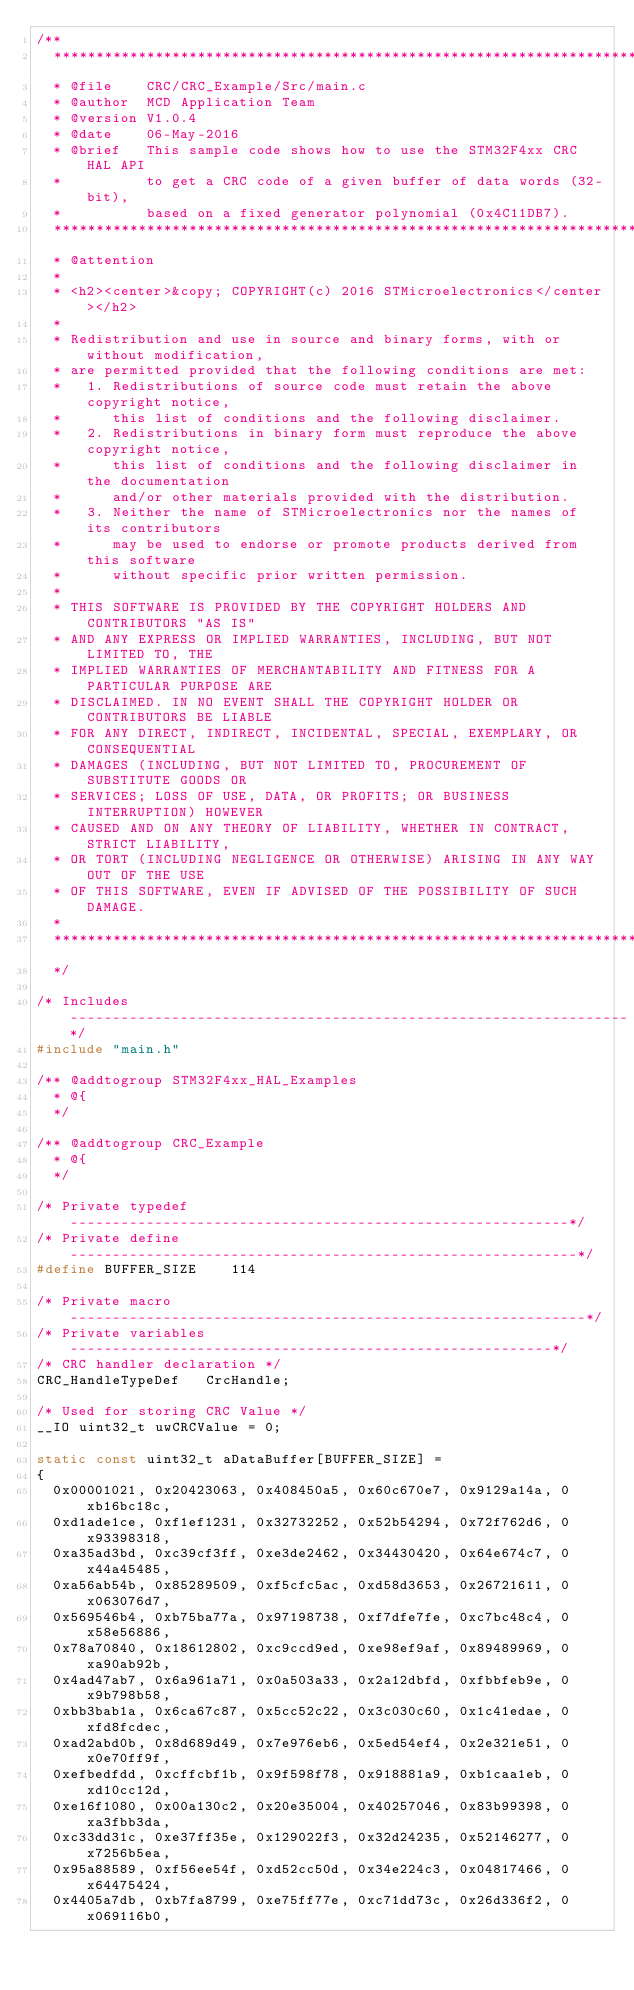Convert code to text. <code><loc_0><loc_0><loc_500><loc_500><_C_>/**
  ******************************************************************************
  * @file    CRC/CRC_Example/Src/main.c
  * @author  MCD Application Team
  * @version V1.0.4
  * @date    06-May-2016
  * @brief   This sample code shows how to use the STM32F4xx CRC HAL API
  *          to get a CRC code of a given buffer of data words (32-bit),
  *          based on a fixed generator polynomial (0x4C11DB7).
  ******************************************************************************
  * @attention
  *
  * <h2><center>&copy; COPYRIGHT(c) 2016 STMicroelectronics</center></h2>
  *
  * Redistribution and use in source and binary forms, with or without modification,
  * are permitted provided that the following conditions are met:
  *   1. Redistributions of source code must retain the above copyright notice,
  *      this list of conditions and the following disclaimer.
  *   2. Redistributions in binary form must reproduce the above copyright notice,
  *      this list of conditions and the following disclaimer in the documentation
  *      and/or other materials provided with the distribution.
  *   3. Neither the name of STMicroelectronics nor the names of its contributors
  *      may be used to endorse or promote products derived from this software
  *      without specific prior written permission.
  *
  * THIS SOFTWARE IS PROVIDED BY THE COPYRIGHT HOLDERS AND CONTRIBUTORS "AS IS"
  * AND ANY EXPRESS OR IMPLIED WARRANTIES, INCLUDING, BUT NOT LIMITED TO, THE
  * IMPLIED WARRANTIES OF MERCHANTABILITY AND FITNESS FOR A PARTICULAR PURPOSE ARE
  * DISCLAIMED. IN NO EVENT SHALL THE COPYRIGHT HOLDER OR CONTRIBUTORS BE LIABLE
  * FOR ANY DIRECT, INDIRECT, INCIDENTAL, SPECIAL, EXEMPLARY, OR CONSEQUENTIAL
  * DAMAGES (INCLUDING, BUT NOT LIMITED TO, PROCUREMENT OF SUBSTITUTE GOODS OR
  * SERVICES; LOSS OF USE, DATA, OR PROFITS; OR BUSINESS INTERRUPTION) HOWEVER
  * CAUSED AND ON ANY THEORY OF LIABILITY, WHETHER IN CONTRACT, STRICT LIABILITY,
  * OR TORT (INCLUDING NEGLIGENCE OR OTHERWISE) ARISING IN ANY WAY OUT OF THE USE
  * OF THIS SOFTWARE, EVEN IF ADVISED OF THE POSSIBILITY OF SUCH DAMAGE.
  *
  ******************************************************************************
  */

/* Includes ------------------------------------------------------------------*/
#include "main.h"

/** @addtogroup STM32F4xx_HAL_Examples
  * @{
  */

/** @addtogroup CRC_Example
  * @{
  */

/* Private typedef -----------------------------------------------------------*/
/* Private define ------------------------------------------------------------*/
#define BUFFER_SIZE    114

/* Private macro -------------------------------------------------------------*/
/* Private variables ---------------------------------------------------------*/
/* CRC handler declaration */
CRC_HandleTypeDef   CrcHandle;

/* Used for storing CRC Value */
__IO uint32_t uwCRCValue = 0;

static const uint32_t aDataBuffer[BUFFER_SIZE] =
{
  0x00001021, 0x20423063, 0x408450a5, 0x60c670e7, 0x9129a14a, 0xb16bc18c,
  0xd1ade1ce, 0xf1ef1231, 0x32732252, 0x52b54294, 0x72f762d6, 0x93398318,
  0xa35ad3bd, 0xc39cf3ff, 0xe3de2462, 0x34430420, 0x64e674c7, 0x44a45485,
  0xa56ab54b, 0x85289509, 0xf5cfc5ac, 0xd58d3653, 0x26721611, 0x063076d7,
  0x569546b4, 0xb75ba77a, 0x97198738, 0xf7dfe7fe, 0xc7bc48c4, 0x58e56886,
  0x78a70840, 0x18612802, 0xc9ccd9ed, 0xe98ef9af, 0x89489969, 0xa90ab92b,
  0x4ad47ab7, 0x6a961a71, 0x0a503a33, 0x2a12dbfd, 0xfbbfeb9e, 0x9b798b58,
  0xbb3bab1a, 0x6ca67c87, 0x5cc52c22, 0x3c030c60, 0x1c41edae, 0xfd8fcdec,
  0xad2abd0b, 0x8d689d49, 0x7e976eb6, 0x5ed54ef4, 0x2e321e51, 0x0e70ff9f,
  0xefbedfdd, 0xcffcbf1b, 0x9f598f78, 0x918881a9, 0xb1caa1eb, 0xd10cc12d,
  0xe16f1080, 0x00a130c2, 0x20e35004, 0x40257046, 0x83b99398, 0xa3fbb3da,
  0xc33dd31c, 0xe37ff35e, 0x129022f3, 0x32d24235, 0x52146277, 0x7256b5ea,
  0x95a88589, 0xf56ee54f, 0xd52cc50d, 0x34e224c3, 0x04817466, 0x64475424,
  0x4405a7db, 0xb7fa8799, 0xe75ff77e, 0xc71dd73c, 0x26d336f2, 0x069116b0,</code> 